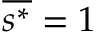<formula> <loc_0><loc_0><loc_500><loc_500>\overline { { s ^ { * } } } = 1</formula> 